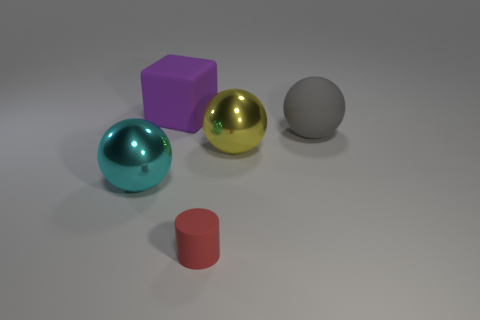Is there any other thing that is the same size as the cylinder?
Make the answer very short. No. Do the yellow sphere and the matte object that is in front of the big cyan ball have the same size?
Offer a very short reply. No. What number of objects are either cyan metallic objects on the left side of the big yellow object or cyan objects?
Keep it short and to the point. 1. The metal thing on the right side of the tiny red thing has what shape?
Give a very brief answer. Sphere. Is the number of large rubber balls left of the block the same as the number of large cyan spheres that are behind the red matte cylinder?
Make the answer very short. No. What is the color of the object that is both behind the small cylinder and in front of the yellow metallic thing?
Offer a terse response. Cyan. What material is the big object in front of the shiny thing behind the cyan thing made of?
Give a very brief answer. Metal. Do the matte ball and the cylinder have the same size?
Offer a terse response. No. What number of small things are gray rubber cylinders or metallic spheres?
Your answer should be very brief. 0. How many rubber objects are to the right of the big rubber cube?
Give a very brief answer. 2. 